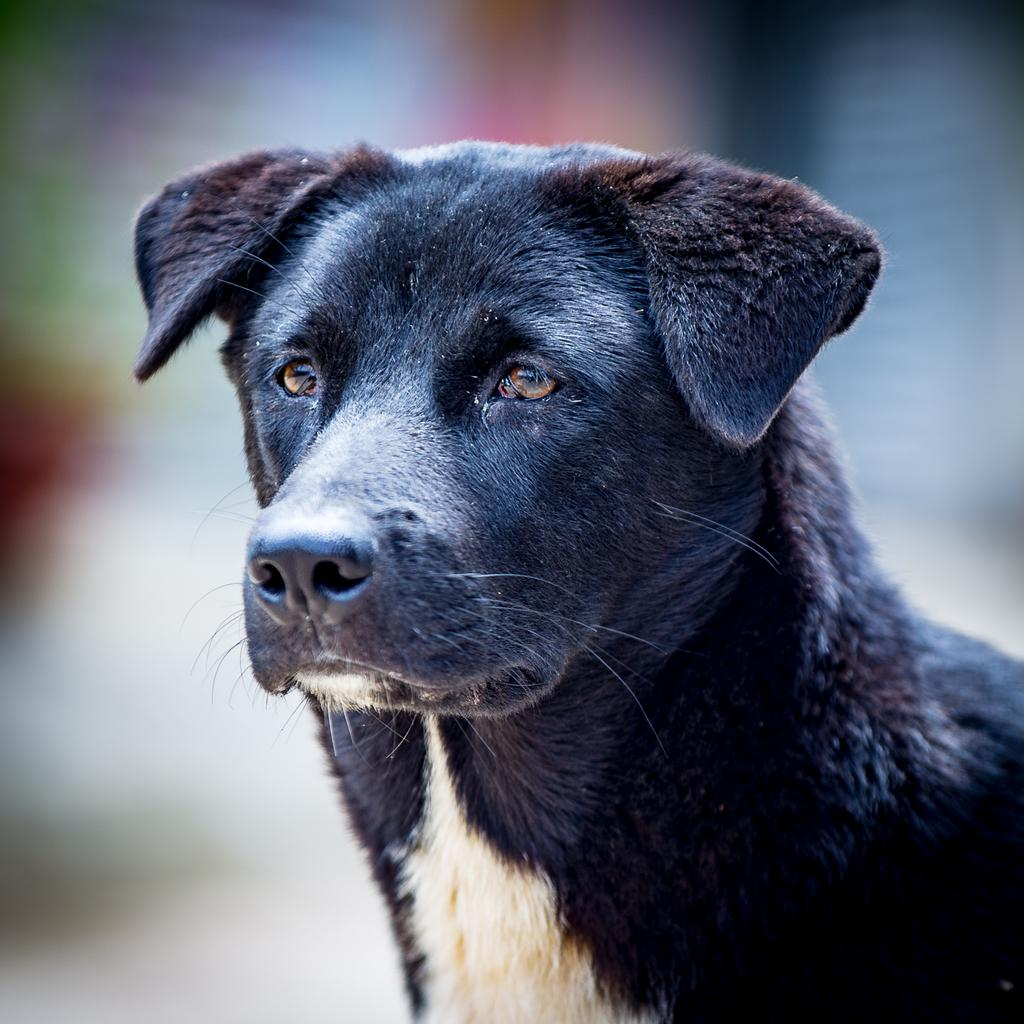What type of animal is in the image? There is a dog in the image. Can you describe the background of the image? The background of the image is blurred. What type of offer is the dog making in the image? There is no indication in the image that the dog is making any offer. 